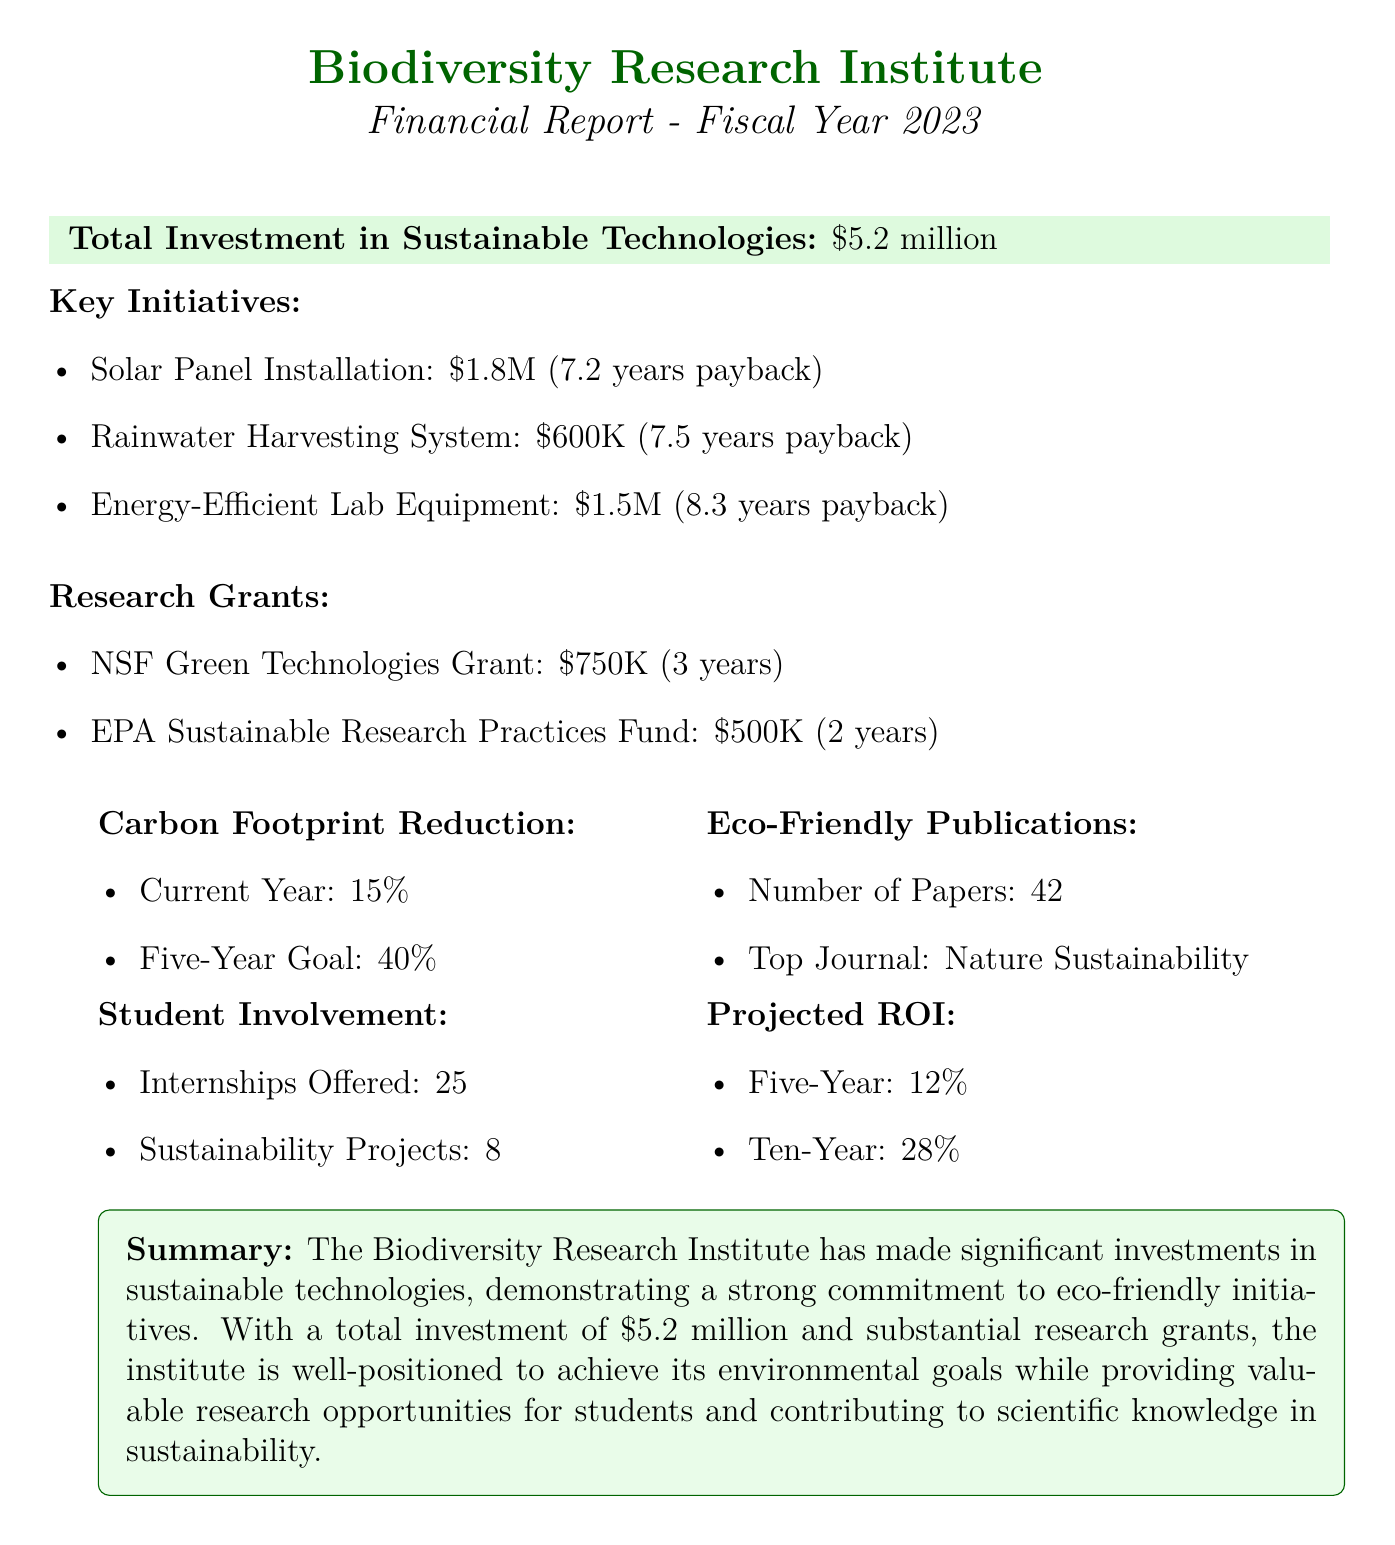What is the total investment made in sustainable technologies? The total investment is explicitly stated in the document as $5.2 million.
Answer: $5.2 million How much was invested in the Solar Panel Installation initiative? The document specifies the cost of the Solar Panel Installation initiative as $1.8 million.
Answer: $1.8 million What is the estimated payback period for the Rainwater Harvesting System? The estimated payback period for this initiative is indicated as 7.5 years in the document.
Answer: 7.5 years How many research grants were received and what is their total amount? The document lists two research grants with amounts of $750,000 and $500,000, totaling $1.25 million.
Answer: $1.25 million What is the current year carbon footprint reduction percentage? The document states that the carbon footprint reduction for the current year is 15%.
Answer: 15% What is the projected ROI for ten years? The projected ROI for ten years is stated as 28% in the document.
Answer: 28% How many internships were offered in the fiscal year 2023? The document specifies that 25 internships were offered during the fiscal year.
Answer: 25 Which top journal was mentioned for eco-friendly publications? The document indicates that the top journal for eco-friendly publications is Nature Sustainability.
Answer: Nature Sustainability What is the five-year goal for carbon footprint reduction? The document specifies the five-year goal for carbon footprint reduction as 40%.
Answer: 40% 